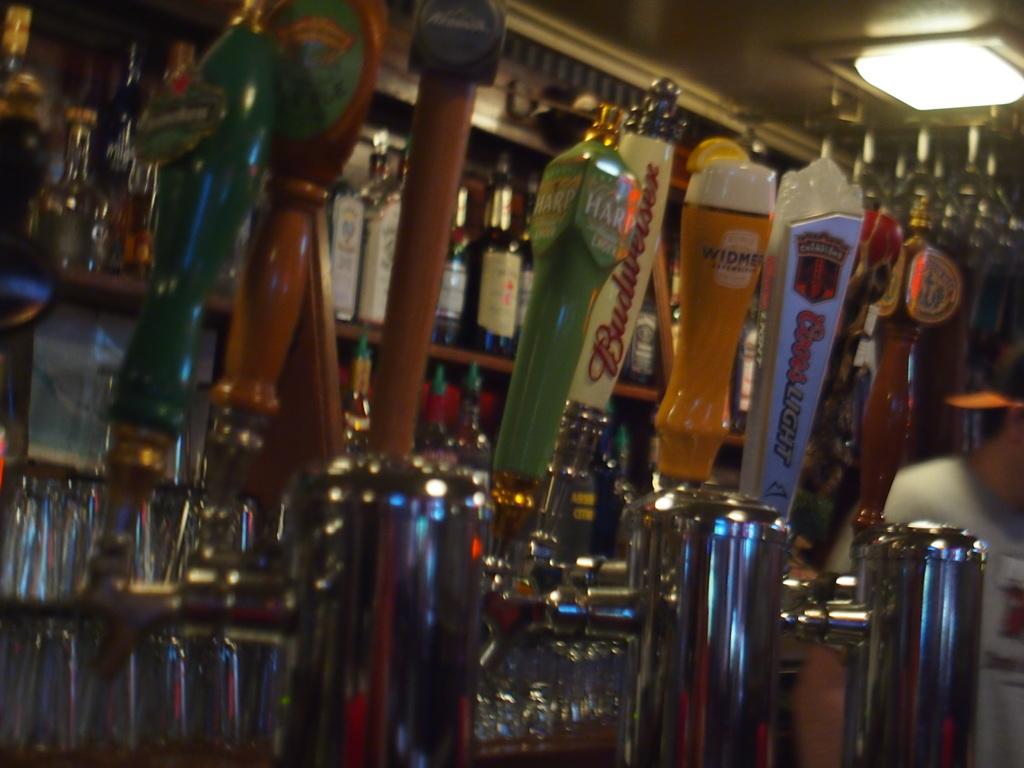Which beer tap starts with a b?
Make the answer very short. Budweiser. Is that apple cinder beer?
Keep it short and to the point. Unanswerable. 